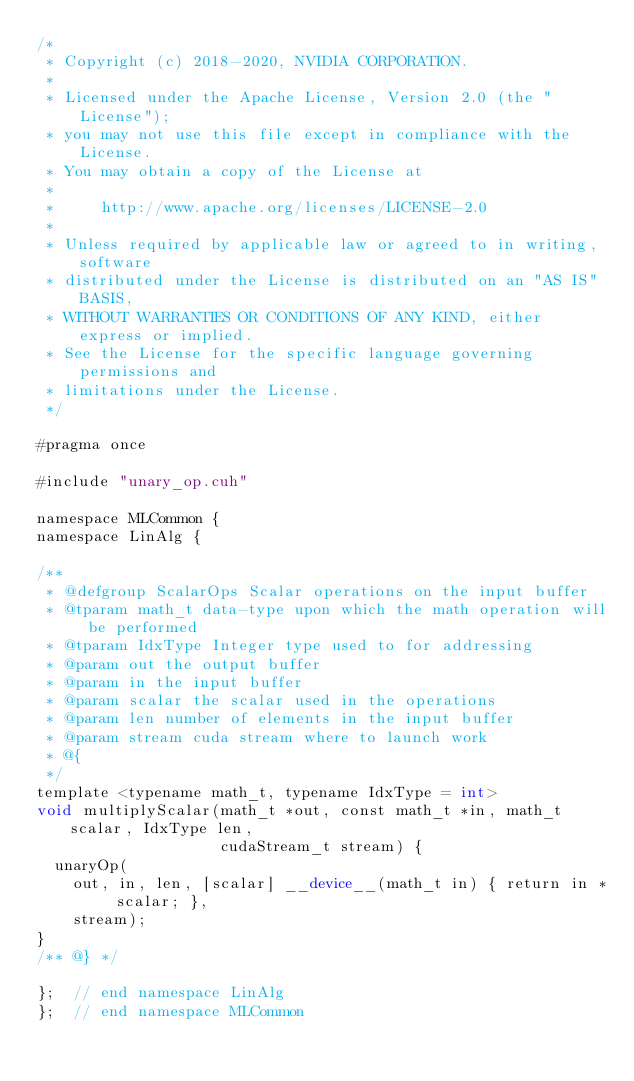Convert code to text. <code><loc_0><loc_0><loc_500><loc_500><_Cuda_>/*
 * Copyright (c) 2018-2020, NVIDIA CORPORATION.
 *
 * Licensed under the Apache License, Version 2.0 (the "License");
 * you may not use this file except in compliance with the License.
 * You may obtain a copy of the License at
 *
 *     http://www.apache.org/licenses/LICENSE-2.0
 *
 * Unless required by applicable law or agreed to in writing, software
 * distributed under the License is distributed on an "AS IS" BASIS,
 * WITHOUT WARRANTIES OR CONDITIONS OF ANY KIND, either express or implied.
 * See the License for the specific language governing permissions and
 * limitations under the License.
 */

#pragma once

#include "unary_op.cuh"

namespace MLCommon {
namespace LinAlg {

/**
 * @defgroup ScalarOps Scalar operations on the input buffer
 * @tparam math_t data-type upon which the math operation will be performed
 * @tparam IdxType Integer type used to for addressing
 * @param out the output buffer
 * @param in the input buffer
 * @param scalar the scalar used in the operations
 * @param len number of elements in the input buffer
 * @param stream cuda stream where to launch work
 * @{
 */
template <typename math_t, typename IdxType = int>
void multiplyScalar(math_t *out, const math_t *in, math_t scalar, IdxType len,
                    cudaStream_t stream) {
  unaryOp(
    out, in, len, [scalar] __device__(math_t in) { return in * scalar; },
    stream);
}
/** @} */

};  // end namespace LinAlg
};  // end namespace MLCommon
</code> 